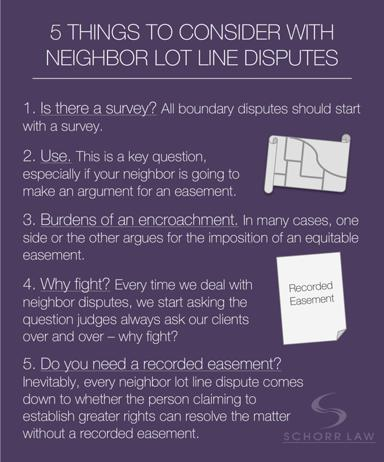Why is it important to consider why neighbors are fighting according to the guide? Understanding the underlying reasons for a dispute between neighbors is significant as identified in the guide. This helps in addressing the core issues, not just the symptoms, and can lead to a more effective and amicable resolution. The guide implies that frequently, legal battles are about more than just the physical boundaries—it's essential to understand all facets of the conflict. 